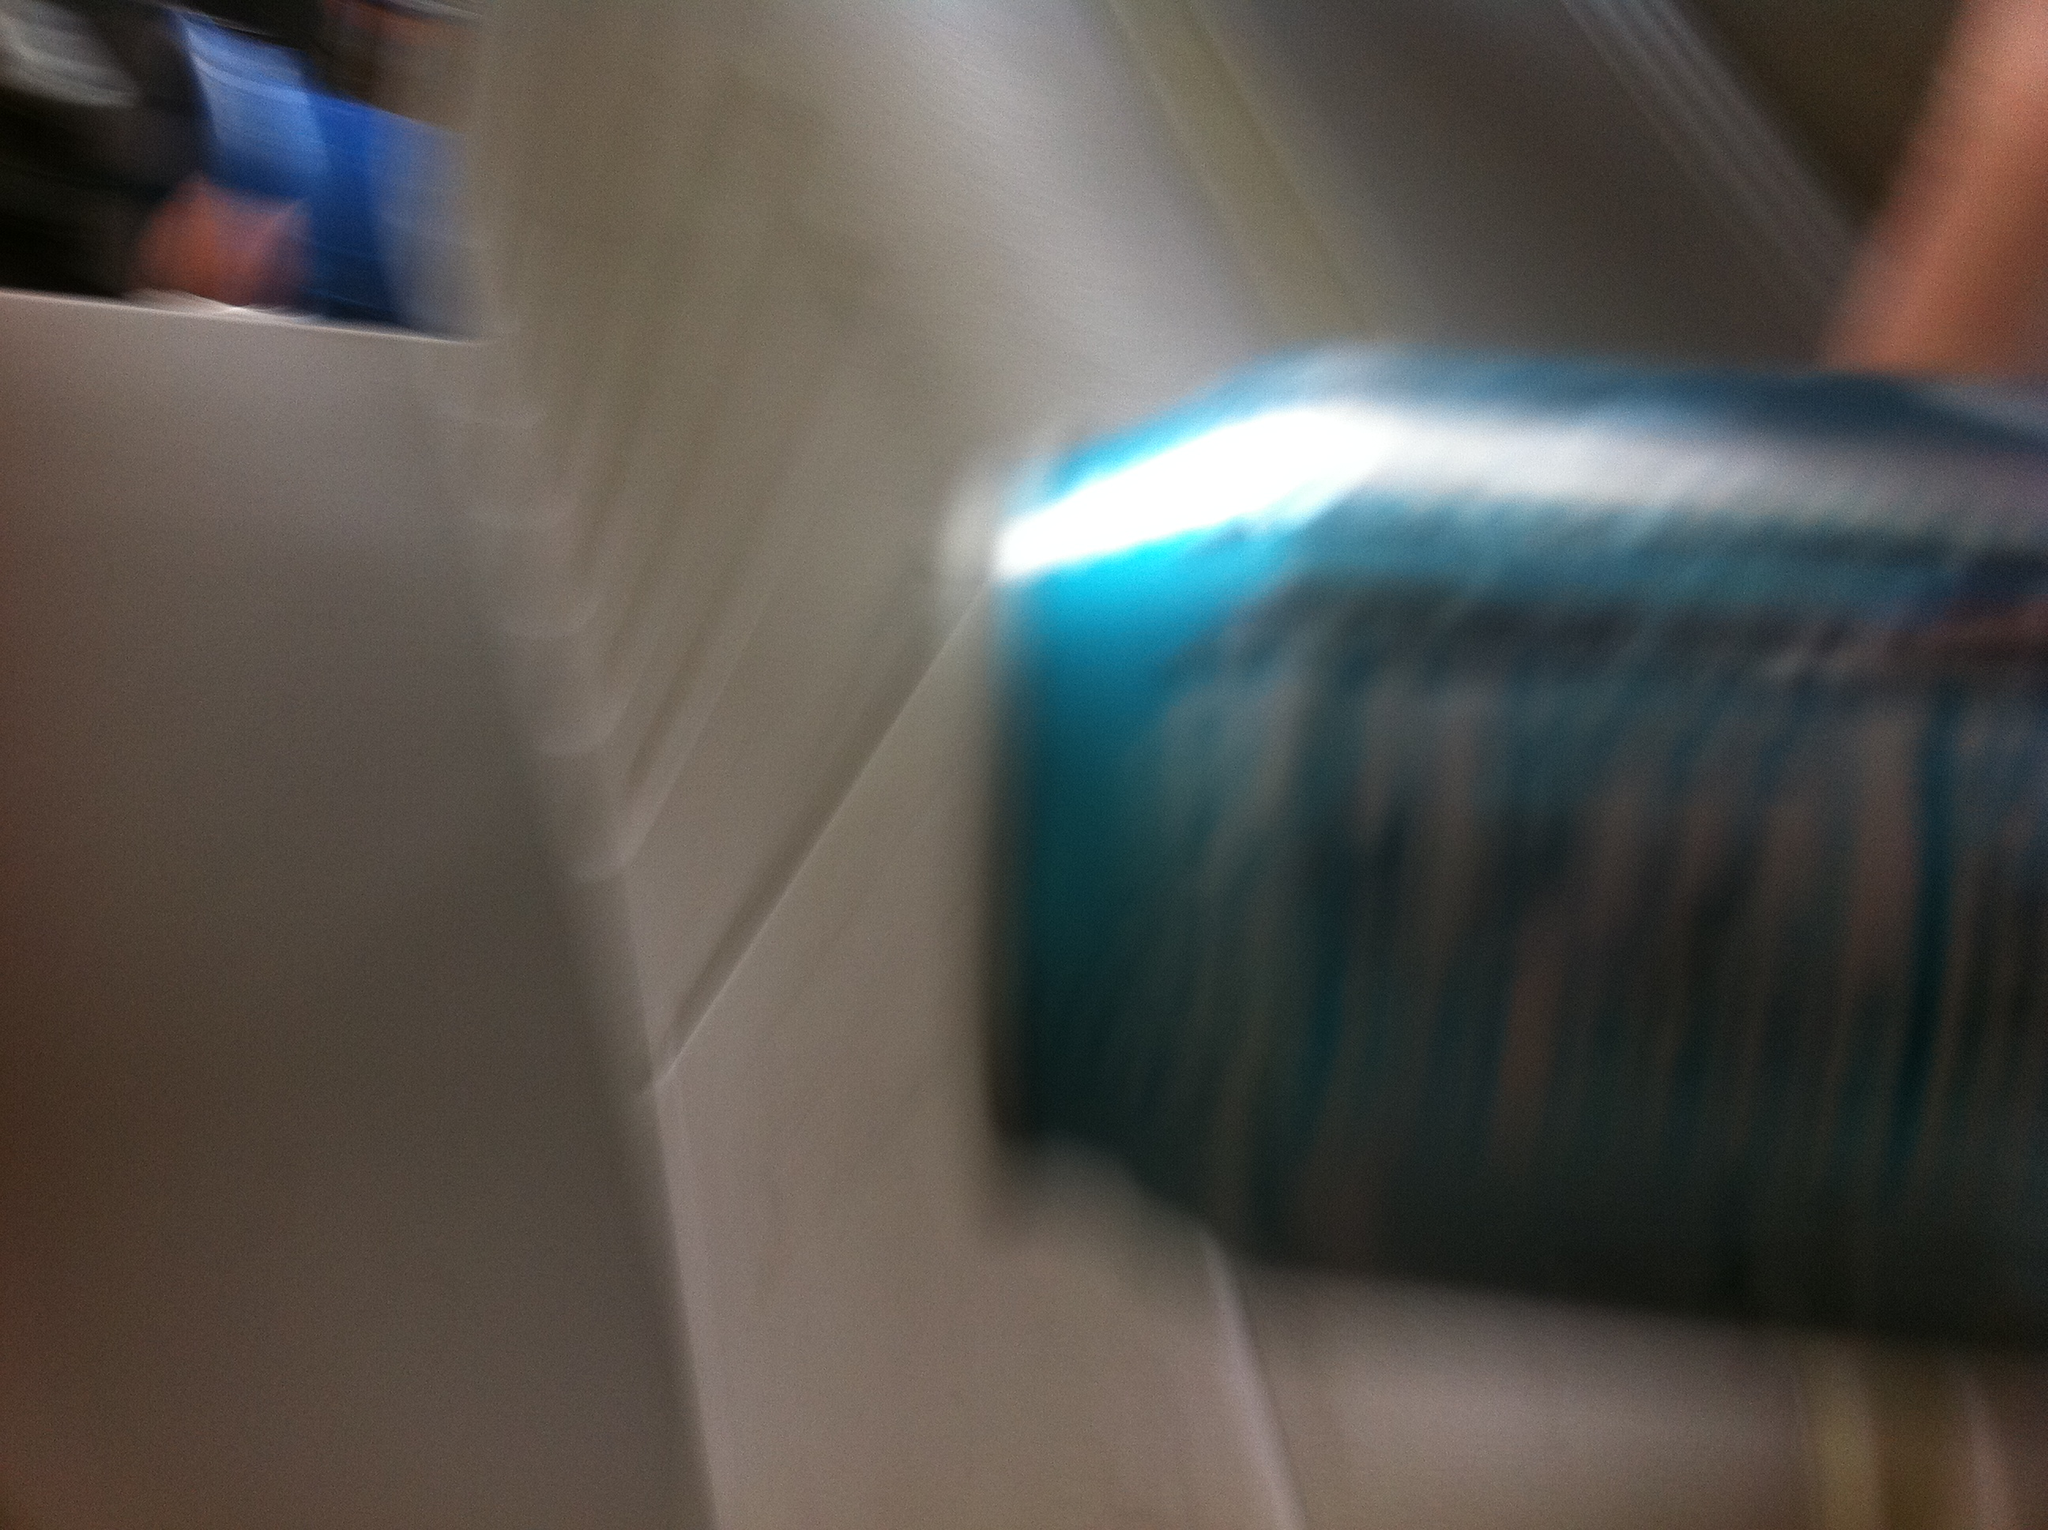What type of soda is this? The image is quite blurry, making it difficult to accurately identify the type of soda. It appears to be a can with blue and possibly white colors on it, but without clearer details, determining the specific type of soda is challenging. 